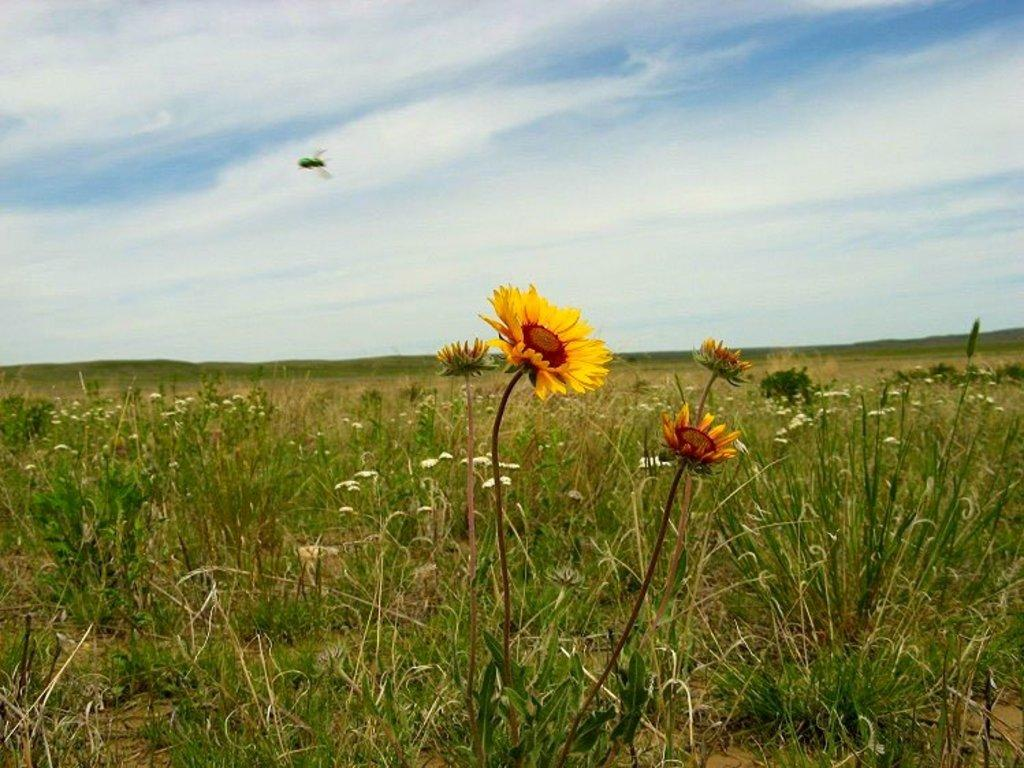What type of plants can be seen in the image? There are plants with flowers in the image. What else is visible in the background of the image? There is grass and the sky visible in the background of the image. Can you describe the insect in the image? There is an insect in the air in the background of the image. What is the condition of the sky in the image? Clouds are present in the sky in the image. What type of competition is taking place in the image? There is no competition present in the image; it features plants, an insect, grass, and the sky. How does the heat affect the plants in the image? The image does not provide information about the temperature or heat, so it cannot be determined how it affects the plants. 